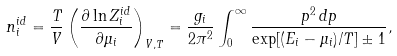Convert formula to latex. <formula><loc_0><loc_0><loc_500><loc_500>n _ { i } ^ { i d } = \frac { T } { V } \left ( \frac { \partial \ln Z _ { i } ^ { i d } } { \partial \mu _ { i } } \right ) _ { V , T } = \frac { g _ { i } } { 2 \pi ^ { 2 } } \int _ { 0 } ^ { \infty } \frac { p ^ { 2 } \, d p } { \exp [ ( E _ { i } - \mu _ { i } ) / T ] \pm 1 } ,</formula> 